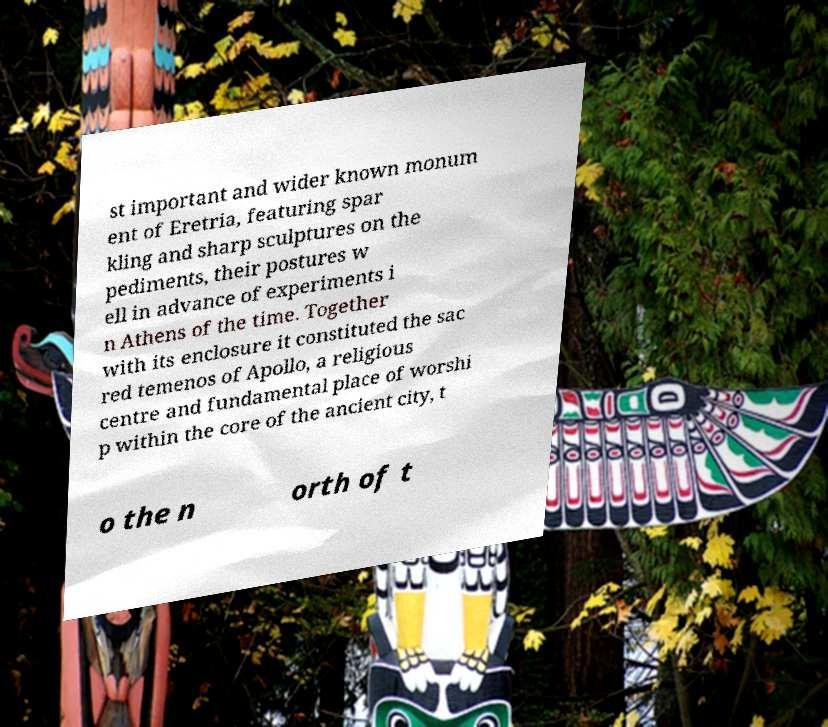Could you assist in decoding the text presented in this image and type it out clearly? st important and wider known monum ent of Eretria, featuring spar kling and sharp sculptures on the pediments, their postures w ell in advance of experiments i n Athens of the time. Together with its enclosure it constituted the sac red temenos of Apollo, a religious centre and fundamental place of worshi p within the core of the ancient city, t o the n orth of t 